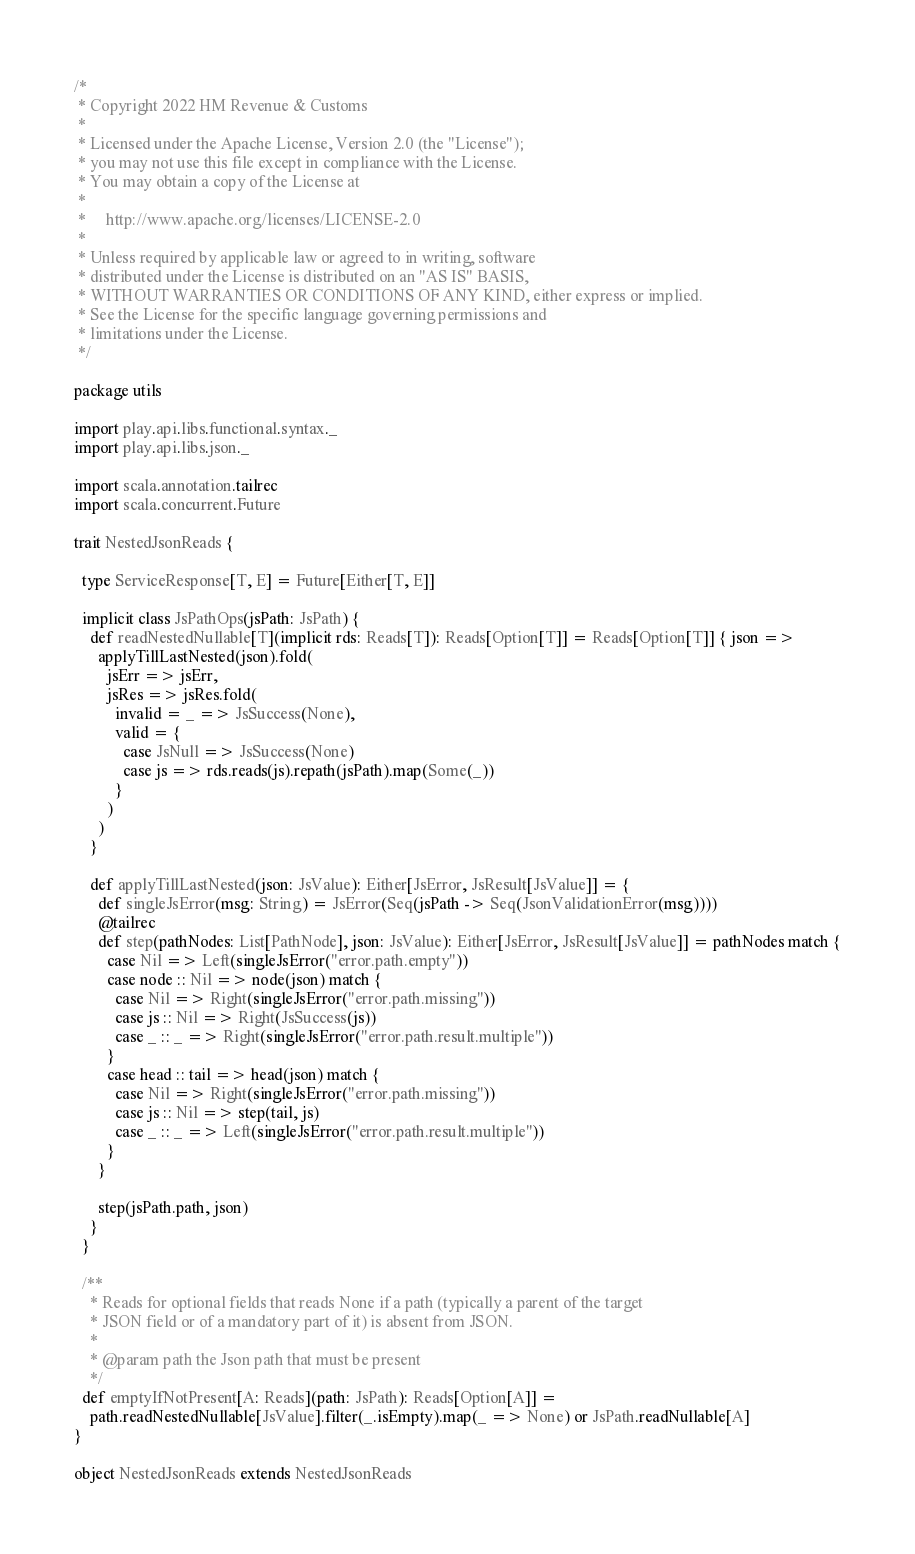<code> <loc_0><loc_0><loc_500><loc_500><_Scala_>/*
 * Copyright 2022 HM Revenue & Customs
 *
 * Licensed under the Apache License, Version 2.0 (the "License");
 * you may not use this file except in compliance with the License.
 * You may obtain a copy of the License at
 *
 *     http://www.apache.org/licenses/LICENSE-2.0
 *
 * Unless required by applicable law or agreed to in writing, software
 * distributed under the License is distributed on an "AS IS" BASIS,
 * WITHOUT WARRANTIES OR CONDITIONS OF ANY KIND, either express or implied.
 * See the License for the specific language governing permissions and
 * limitations under the License.
 */

package utils

import play.api.libs.functional.syntax._
import play.api.libs.json._

import scala.annotation.tailrec
import scala.concurrent.Future

trait NestedJsonReads {

  type ServiceResponse[T, E] = Future[Either[T, E]]

  implicit class JsPathOps(jsPath: JsPath) {
    def readNestedNullable[T](implicit rds: Reads[T]): Reads[Option[T]] = Reads[Option[T]] { json =>
      applyTillLastNested(json).fold(
        jsErr => jsErr,
        jsRes => jsRes.fold(
          invalid = _ => JsSuccess(None),
          valid = {
            case JsNull => JsSuccess(None)
            case js => rds.reads(js).repath(jsPath).map(Some(_))
          }
        )
      )
    }

    def applyTillLastNested(json: JsValue): Either[JsError, JsResult[JsValue]] = {
      def singleJsError(msg: String) = JsError(Seq(jsPath -> Seq(JsonValidationError(msg))))
      @tailrec
      def step(pathNodes: List[PathNode], json: JsValue): Either[JsError, JsResult[JsValue]] = pathNodes match {
        case Nil => Left(singleJsError("error.path.empty"))
        case node :: Nil => node(json) match {
          case Nil => Right(singleJsError("error.path.missing"))
          case js :: Nil => Right(JsSuccess(js))
          case _ :: _ => Right(singleJsError("error.path.result.multiple"))
        }
        case head :: tail => head(json) match {
          case Nil => Right(singleJsError("error.path.missing"))
          case js :: Nil => step(tail, js)
          case _ :: _ => Left(singleJsError("error.path.result.multiple"))
        }
      }

      step(jsPath.path, json)
    }
  }

  /**
    * Reads for optional fields that reads None if a path (typically a parent of the target
    * JSON field or of a mandatory part of it) is absent from JSON.
    *
    * @param path the Json path that must be present
    */
  def emptyIfNotPresent[A: Reads](path: JsPath): Reads[Option[A]] =
    path.readNestedNullable[JsValue].filter(_.isEmpty).map(_ => None) or JsPath.readNullable[A]
}

object NestedJsonReads extends NestedJsonReads
</code> 